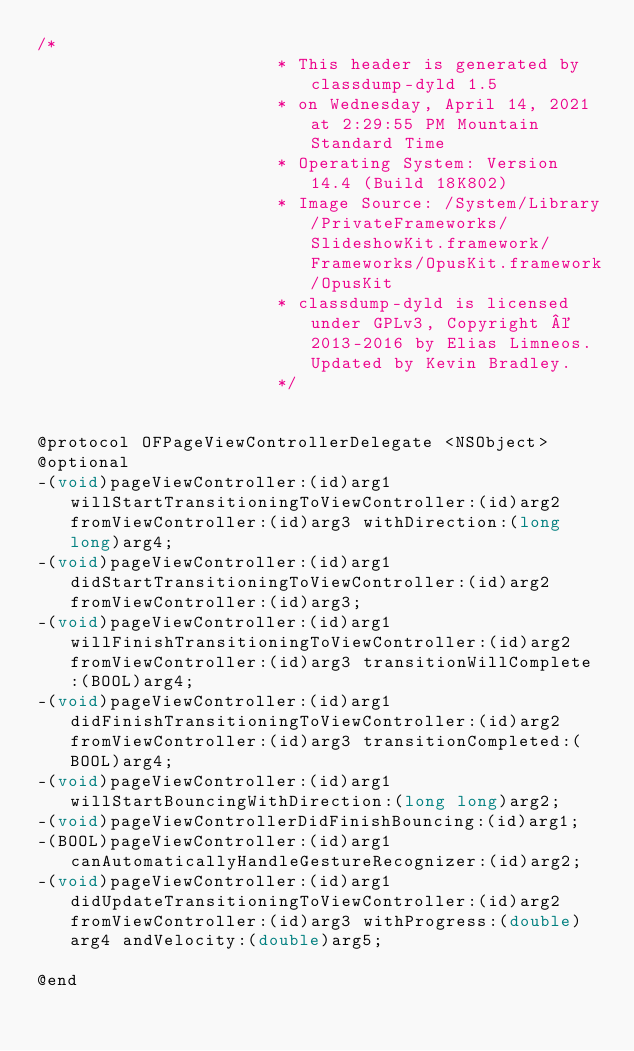<code> <loc_0><loc_0><loc_500><loc_500><_C_>/*
                       * This header is generated by classdump-dyld 1.5
                       * on Wednesday, April 14, 2021 at 2:29:55 PM Mountain Standard Time
                       * Operating System: Version 14.4 (Build 18K802)
                       * Image Source: /System/Library/PrivateFrameworks/SlideshowKit.framework/Frameworks/OpusKit.framework/OpusKit
                       * classdump-dyld is licensed under GPLv3, Copyright © 2013-2016 by Elias Limneos. Updated by Kevin Bradley.
                       */


@protocol OFPageViewControllerDelegate <NSObject>
@optional
-(void)pageViewController:(id)arg1 willStartTransitioningToViewController:(id)arg2 fromViewController:(id)arg3 withDirection:(long long)arg4;
-(void)pageViewController:(id)arg1 didStartTransitioningToViewController:(id)arg2 fromViewController:(id)arg3;
-(void)pageViewController:(id)arg1 willFinishTransitioningToViewController:(id)arg2 fromViewController:(id)arg3 transitionWillComplete:(BOOL)arg4;
-(void)pageViewController:(id)arg1 didFinishTransitioningToViewController:(id)arg2 fromViewController:(id)arg3 transitionCompleted:(BOOL)arg4;
-(void)pageViewController:(id)arg1 willStartBouncingWithDirection:(long long)arg2;
-(void)pageViewControllerDidFinishBouncing:(id)arg1;
-(BOOL)pageViewController:(id)arg1 canAutomaticallyHandleGestureRecognizer:(id)arg2;
-(void)pageViewController:(id)arg1 didUpdateTransitioningToViewController:(id)arg2 fromViewController:(id)arg3 withProgress:(double)arg4 andVelocity:(double)arg5;

@end

</code> 